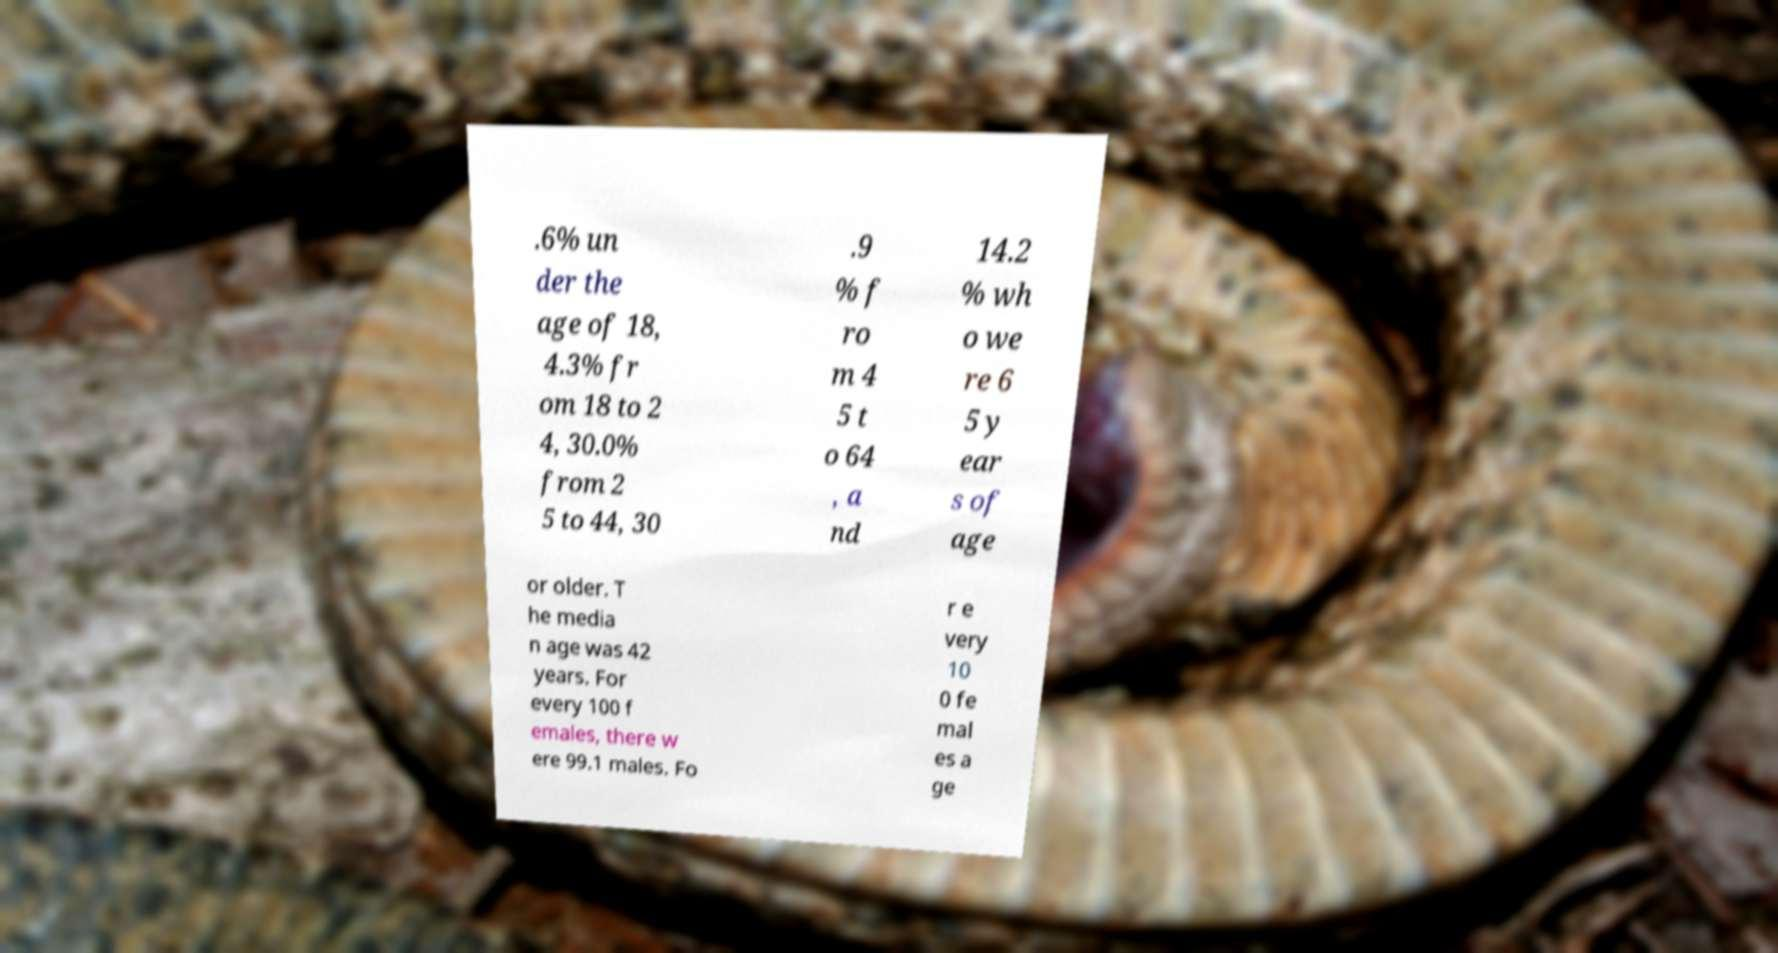Can you accurately transcribe the text from the provided image for me? .6% un der the age of 18, 4.3% fr om 18 to 2 4, 30.0% from 2 5 to 44, 30 .9 % f ro m 4 5 t o 64 , a nd 14.2 % wh o we re 6 5 y ear s of age or older. T he media n age was 42 years. For every 100 f emales, there w ere 99.1 males. Fo r e very 10 0 fe mal es a ge 